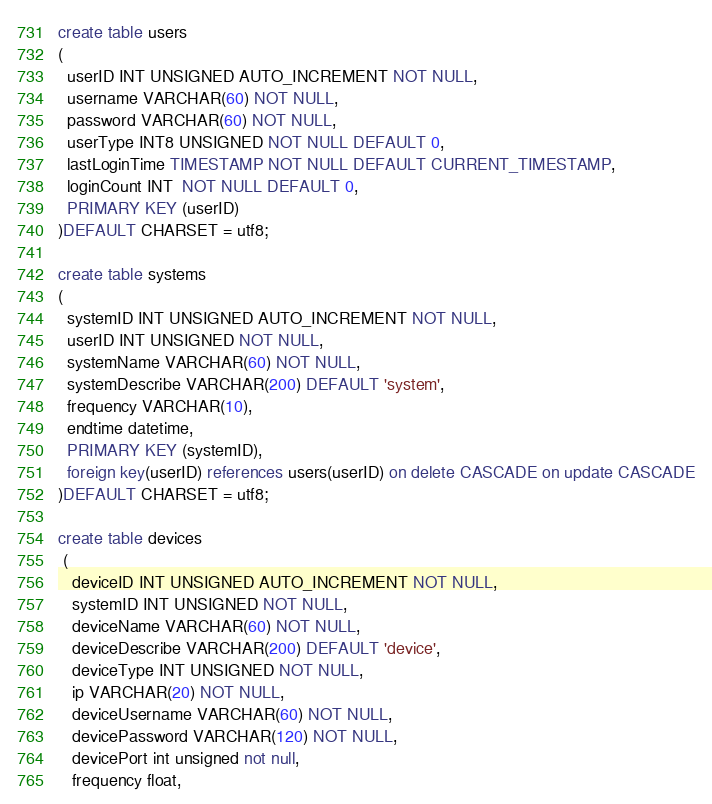<code> <loc_0><loc_0><loc_500><loc_500><_SQL_>create table users
(
  userID INT UNSIGNED AUTO_INCREMENT NOT NULL,
  username VARCHAR(60) NOT NULL,
  password VARCHAR(60) NOT NULL,
  userType INT8 UNSIGNED NOT NULL DEFAULT 0,
  lastLoginTime TIMESTAMP NOT NULL DEFAULT CURRENT_TIMESTAMP,
  loginCount INT  NOT NULL DEFAULT 0,
  PRIMARY KEY (userID)
)DEFAULT CHARSET = utf8;

create table systems
(
  systemID INT UNSIGNED AUTO_INCREMENT NOT NULL,
  userID INT UNSIGNED NOT NULL,
  systemName VARCHAR(60) NOT NULL,
  systemDescribe VARCHAR(200) DEFAULT 'system',
  frequency VARCHAR(10),
  endtime datetime,
  PRIMARY KEY (systemID),
  foreign key(userID) references users(userID) on delete CASCADE on update CASCADE
)DEFAULT CHARSET = utf8;

create table devices
 (
   deviceID INT UNSIGNED AUTO_INCREMENT NOT NULL,
   systemID INT UNSIGNED NOT NULL,
   deviceName VARCHAR(60) NOT NULL,
   deviceDescribe VARCHAR(200) DEFAULT 'device',
   deviceType INT UNSIGNED NOT NULL,
   ip VARCHAR(20) NOT NULL,
   deviceUsername VARCHAR(60) NOT NULL,
   devicePassword VARCHAR(120) NOT NULL,
   devicePort int unsigned not null,
   frequency float,</code> 